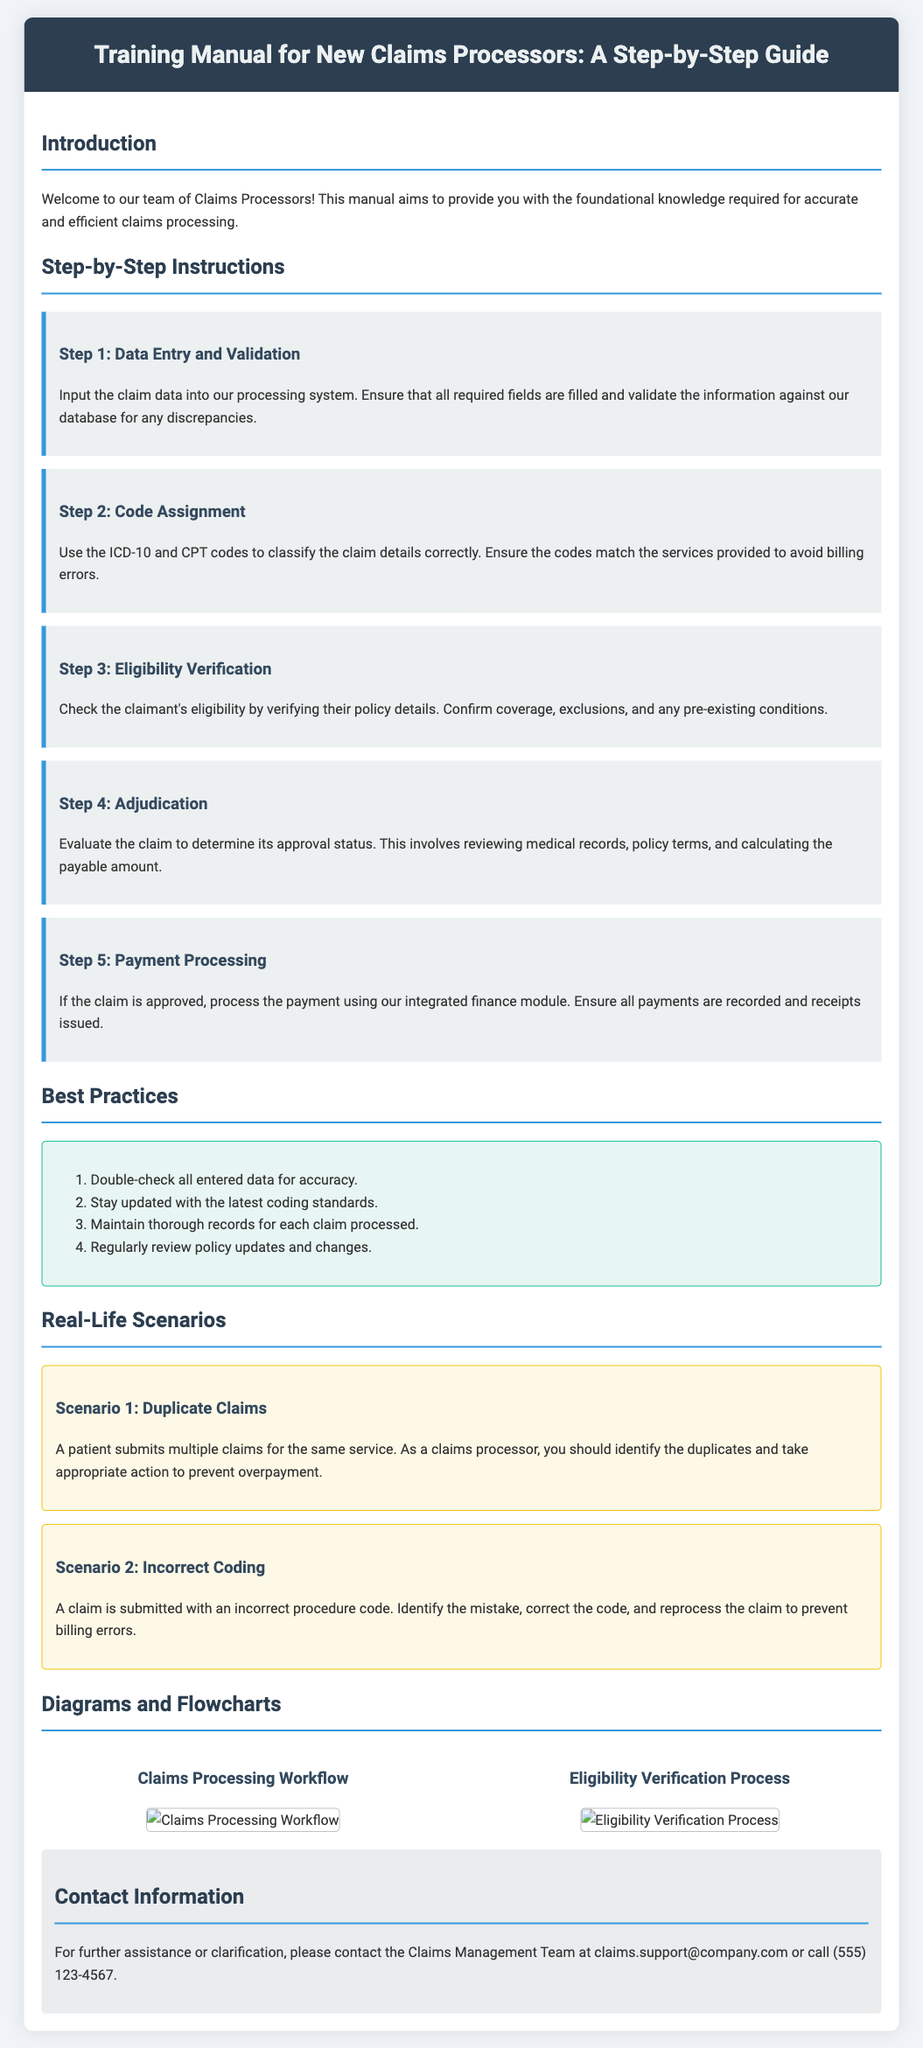What is the title of the manual? The title of the manual is found in the header section.
Answer: Training Manual for New Claims Processors: A Step-by-Step Guide How many steps are there in the claims processing instructions? The number of steps is indicated in the section detailing the step-by-step instructions.
Answer: Five What is the first step in the claims processing procedure? The first step is listed at the beginning of the step-by-step instructions section.
Answer: Data Entry and Validation Which ICD standard is referenced for code assignment? The standard for coding is mentioned explicitly in the code assignment section.
Answer: ICD-10 What color is used for the best practices section background? The background color can be identified by examining the styling attributes of the best practices section.
Answer: Light green What is a scenario mentioned related to claims processing? The scenarios are provided in the section dedicated to real-life scenarios, which highlights specific issues in claims processing.
Answer: Duplicate Claims Who can you contact for further assistance? The contact information is provided at the end of the document, listing who to reach out to for help.
Answer: Claims Management Team How many real-life scenarios are presented in the manual? The number of scenarios is specified in the real-life scenarios section of the document.
Answer: Two What action is suggested for a claim with incorrect coding? The suggested action is provided within the context of the real-life scenarios section addressing incorrect coding.
Answer: Identify the mistake, correct the code, and reprocess the claim 